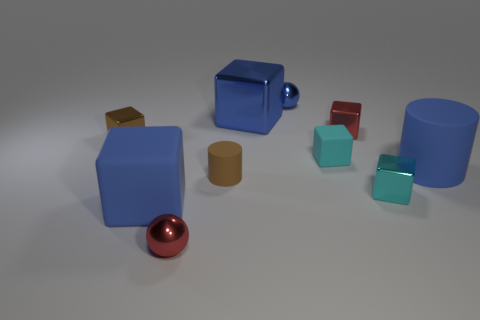Subtract all red blocks. How many blocks are left? 5 Subtract 4 cubes. How many cubes are left? 2 Subtract all brown spheres. How many blue cubes are left? 2 Subtract all brown blocks. How many blocks are left? 5 Subtract all gray blocks. Subtract all red cylinders. How many blocks are left? 6 Subtract all balls. How many objects are left? 8 Subtract 0 gray cubes. How many objects are left? 10 Subtract all metal objects. Subtract all tiny brown cylinders. How many objects are left? 3 Add 3 big cylinders. How many big cylinders are left? 4 Add 4 blue objects. How many blue objects exist? 8 